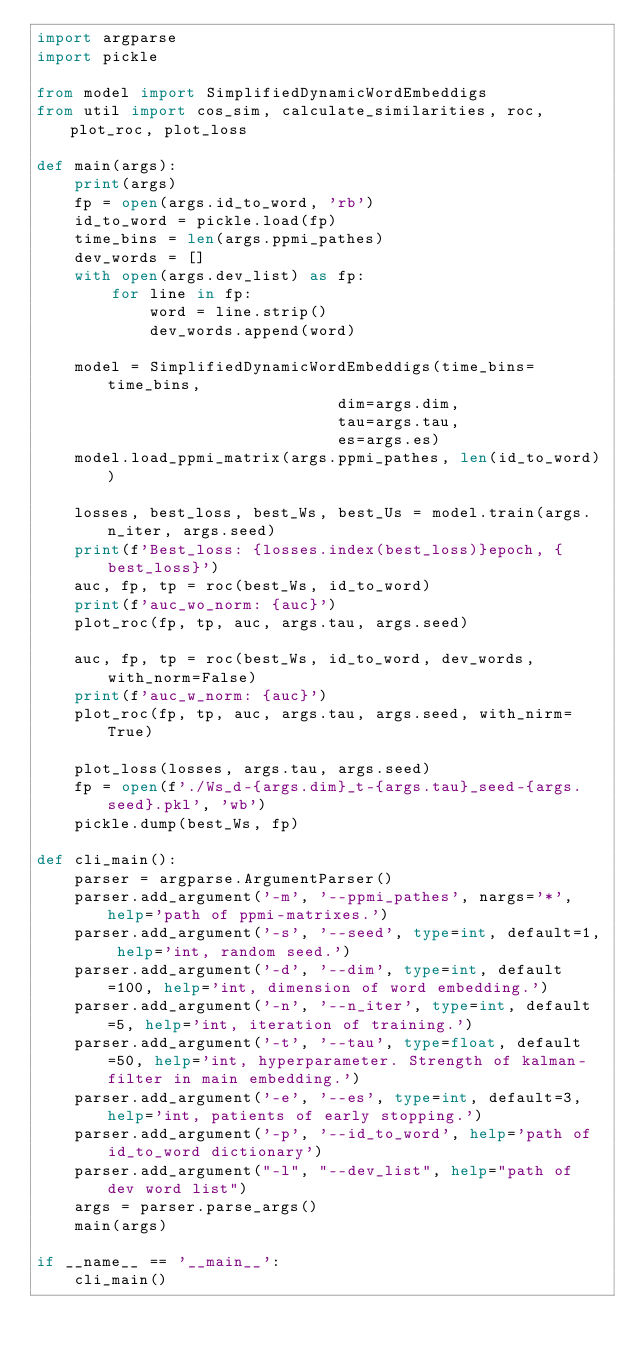<code> <loc_0><loc_0><loc_500><loc_500><_Python_>import argparse
import pickle

from model import SimplifiedDynamicWordEmbeddigs
from util import cos_sim, calculate_similarities, roc, plot_roc, plot_loss

def main(args):
    print(args)
    fp = open(args.id_to_word, 'rb')
    id_to_word = pickle.load(fp)
    time_bins = len(args.ppmi_pathes)
    dev_words = []
    with open(args.dev_list) as fp:
        for line in fp:
            word = line.strip()
            dev_words.append(word)

    model = SimplifiedDynamicWordEmbeddigs(time_bins=time_bins, 
                                dim=args.dim,
                                tau=args.tau,
                                es=args.es)
    model.load_ppmi_matrix(args.ppmi_pathes, len(id_to_word))

    losses, best_loss, best_Ws, best_Us = model.train(args.n_iter, args.seed)
    print(f'Best_loss: {losses.index(best_loss)}epoch, {best_loss}')
    auc, fp, tp = roc(best_Ws, id_to_word)
    print(f'auc_wo_norm: {auc}')
    plot_roc(fp, tp, auc, args.tau, args.seed)

    auc, fp, tp = roc(best_Ws, id_to_word, dev_words, with_norm=False)
    print(f'auc_w_norm: {auc}')
    plot_roc(fp, tp, auc, args.tau, args.seed, with_nirm=True)

    plot_loss(losses, args.tau, args.seed)
    fp = open(f'./Ws_d-{args.dim}_t-{args.tau}_seed-{args.seed}.pkl', 'wb')
    pickle.dump(best_Ws, fp)

def cli_main():
    parser = argparse.ArgumentParser()
    parser.add_argument('-m', '--ppmi_pathes', nargs='*', help='path of ppmi-matrixes.')
    parser.add_argument('-s', '--seed', type=int, default=1, help='int, random seed.')
    parser.add_argument('-d', '--dim', type=int, default=100, help='int, dimension of word embedding.')
    parser.add_argument('-n', '--n_iter', type=int, default=5, help='int, iteration of training.')
    parser.add_argument('-t', '--tau', type=float, default=50, help='int, hyperparameter. Strength of kalman-filter in main embedding.')
    parser.add_argument('-e', '--es', type=int, default=3, help='int, patients of early stopping.')
    parser.add_argument('-p', '--id_to_word', help='path of id_to_word dictionary')
    parser.add_argument("-l", "--dev_list", help="path of dev word list")
    args = parser.parse_args()
    main(args)

if __name__ == '__main__':
    cli_main()
    
</code> 